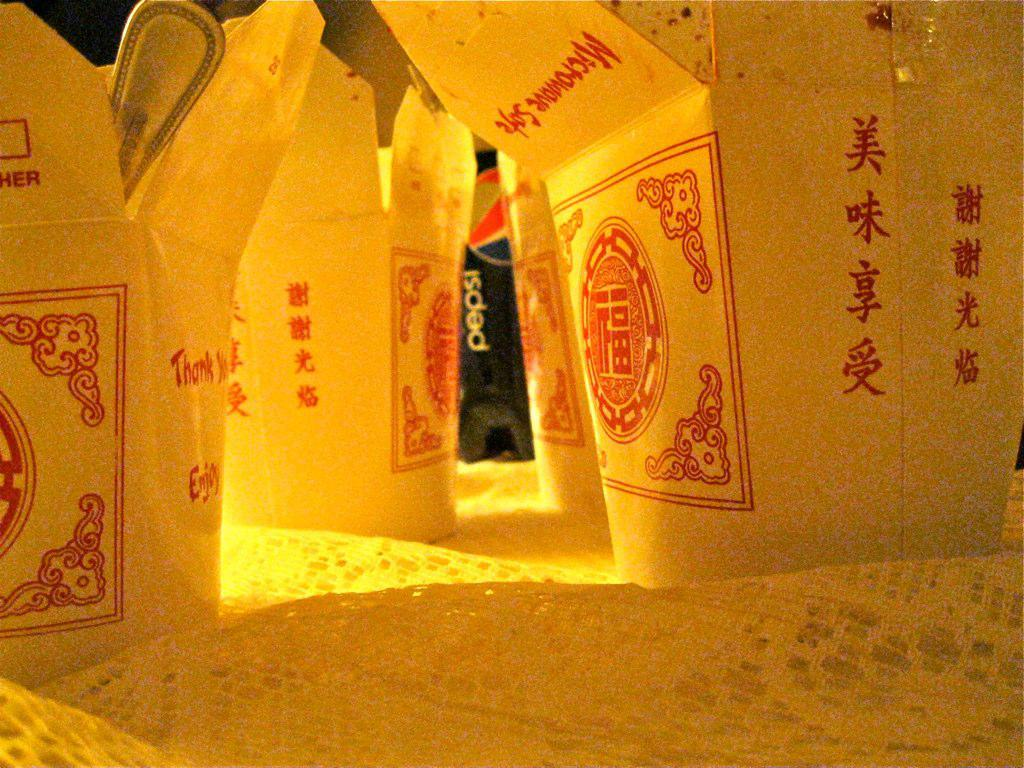<image>
Relay a brief, clear account of the picture shown. A food container states it is microwave safe in red letters. 